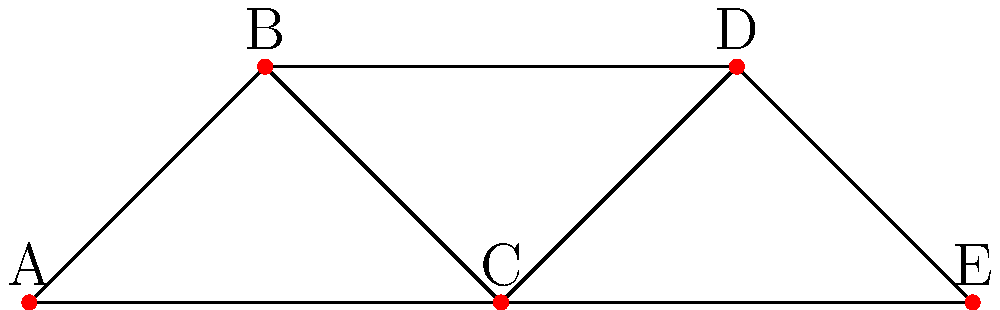In a social network graph representing connections between music festival attendees, node degree indicates the number of connections an attendee has. Given the graph above, which attendee (represented by a node) has the highest degree centrality, and what does this imply about their role in the festival community? To determine the attendee with the highest degree centrality and understand its implications, let's follow these steps:

1. Calculate the degree of each node:
   A: 2 connections (B and C)
   B: 2 connections (A and D)
   C: 3 connections (A, B, and E)
   D: 2 connections (B and E)
   E: 2 connections (C and D)

2. Identify the node with the highest degree:
   Node C has the highest degree with 3 connections.

3. Interpret the meaning of high degree centrality:
   - Higher degree centrality indicates more direct connections to other attendees.
   - It suggests that this attendee is more central to the network and potentially more influential.

4. Implications for the festival community:
   - Attendee C is likely to be a key connector or influencer within the festival community.
   - They may have a broader range of interactions and experiences to share on their travel blog.
   - This attendee might be more likely to spread information quickly or influence others' festival experiences.
   - They could be seen as a hub for social activities or information exchange during the festival.

5. Relevance to the persona:
   As an outgoing social butterfly who blogs about their experiences, having high degree centrality aligns well with the persona's characteristics. This position in the network provides rich material for blog content and enhances their ability to share diverse festival experiences.
Answer: Attendee C; likely a key influencer and connector in the festival community. 